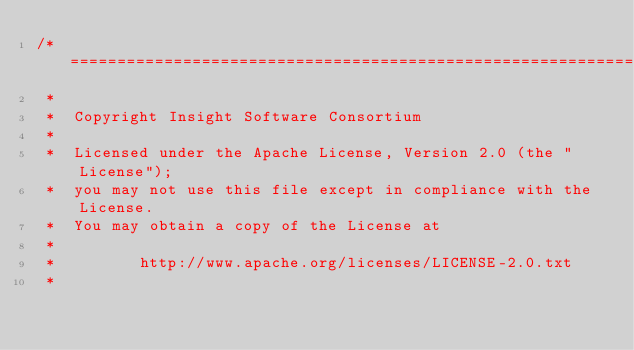Convert code to text. <code><loc_0><loc_0><loc_500><loc_500><_C++_>/*=========================================================================
 *
 *  Copyright Insight Software Consortium
 *
 *  Licensed under the Apache License, Version 2.0 (the "License");
 *  you may not use this file except in compliance with the License.
 *  You may obtain a copy of the License at
 *
 *         http://www.apache.org/licenses/LICENSE-2.0.txt
 *</code> 